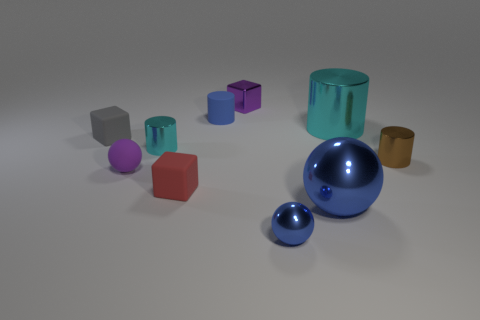Subtract all tiny red cubes. How many cubes are left? 2 Subtract all blue balls. How many cyan cylinders are left? 2 Subtract all blue cylinders. How many cylinders are left? 3 Subtract 1 balls. How many balls are left? 2 Subtract all yellow blocks. Subtract all brown cylinders. How many blocks are left? 3 Subtract all balls. How many objects are left? 7 Add 5 tiny red cubes. How many tiny red cubes exist? 6 Subtract 0 brown cubes. How many objects are left? 10 Subtract all small purple rubber spheres. Subtract all tiny brown cylinders. How many objects are left? 8 Add 5 big blue metallic things. How many big blue metallic things are left? 6 